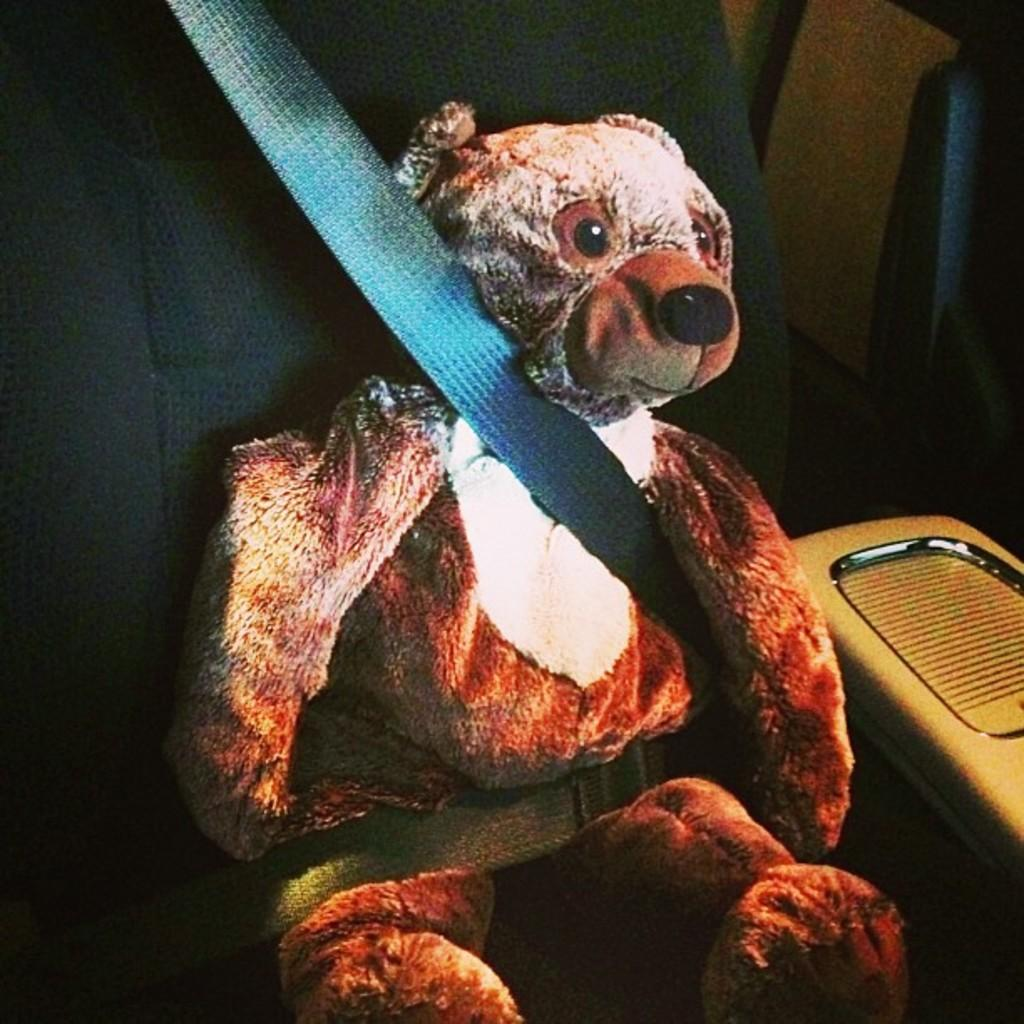Where was the image taken? The image was taken inside a vehicle. What can be seen in one of the seats in the image? There is a teddy bear in a seat in the image. What type of locket is the teddy bear wearing in the image? There is no locket present on the teddy bear in the image. How does the teddy bear provide support to the passengers in the vehicle? The teddy bear is not providing any support to the passengers in the vehicle; it is simply sitting in a seat. 